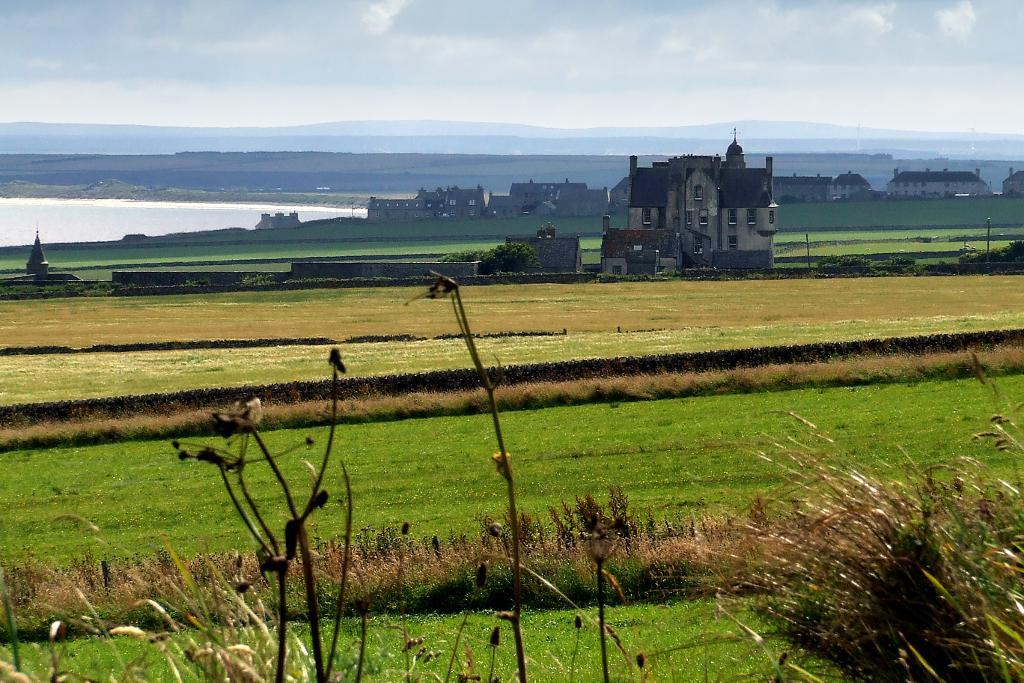What type of terrain is visible at the bottom of the image? There is grass at the bottom of the image. What can be seen in the distance in the image? There are buildings, grass, poles, and clouds in the background of the image. Is there any water visible in the image? Yes, there is water on the left side of the image. What type of theory is being proposed by the eggs in the image? There are no eggs present in the image, so no theory can be proposed by them. 